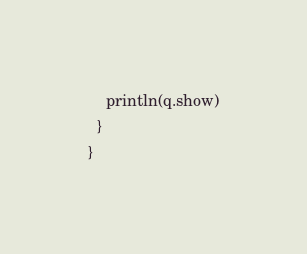<code> <loc_0><loc_0><loc_500><loc_500><_Scala_>
    println(q.show)
  }
}
</code> 